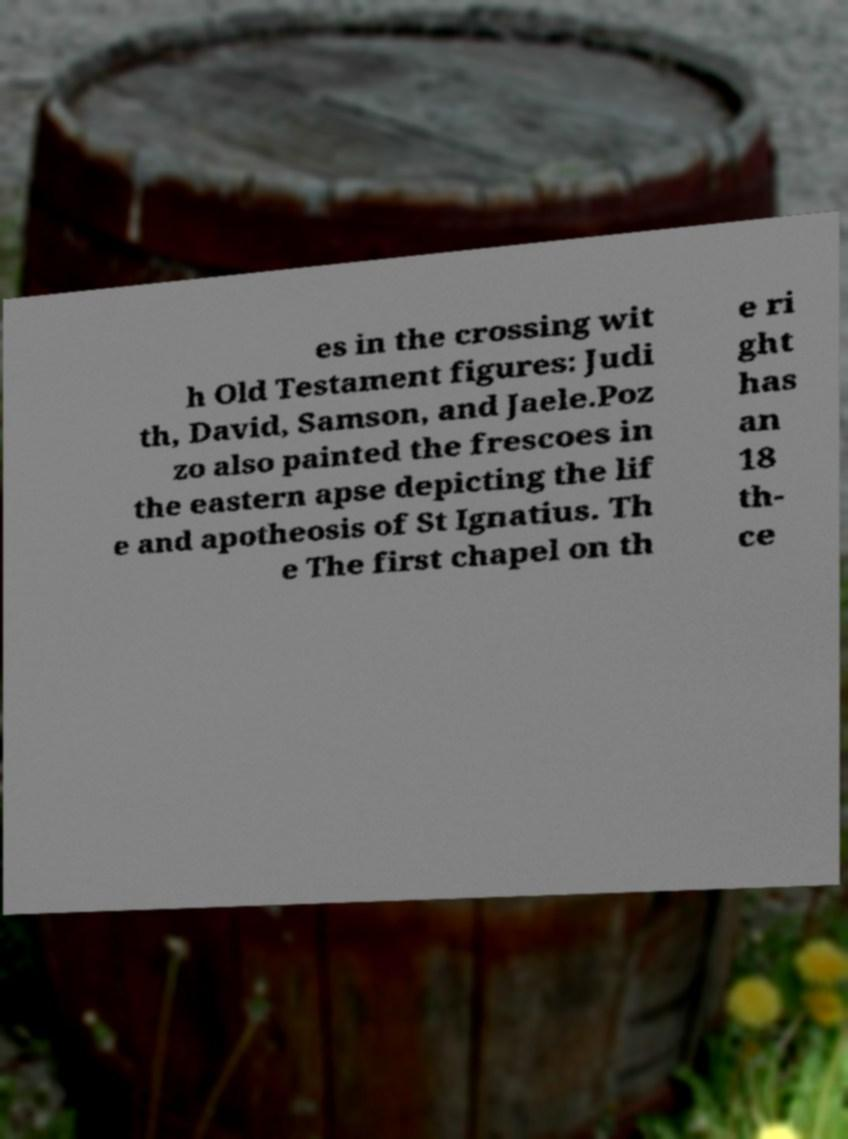There's text embedded in this image that I need extracted. Can you transcribe it verbatim? es in the crossing wit h Old Testament figures: Judi th, David, Samson, and Jaele.Poz zo also painted the frescoes in the eastern apse depicting the lif e and apotheosis of St Ignatius. Th e The first chapel on th e ri ght has an 18 th- ce 